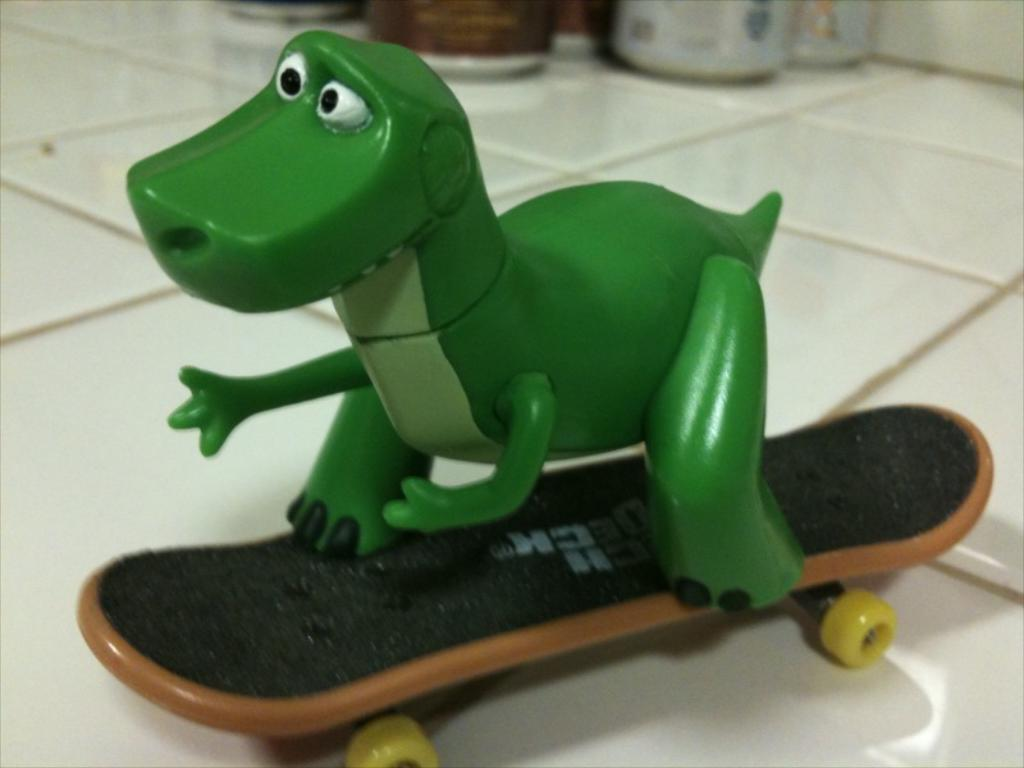What type of object is in the image? There is a toy animal in the image. What is the toy animal doing in the image? The toy animal is on a skateboard. What color is the toy animal? The toy animal is green in color. What color is the background of the image? The background of the image is white. How many trucks are visible in the image? There are no trucks visible in the image; it features a toy animal on a skateboard against a white background. Can you see a duck in the image? There is no duck present in the image. 